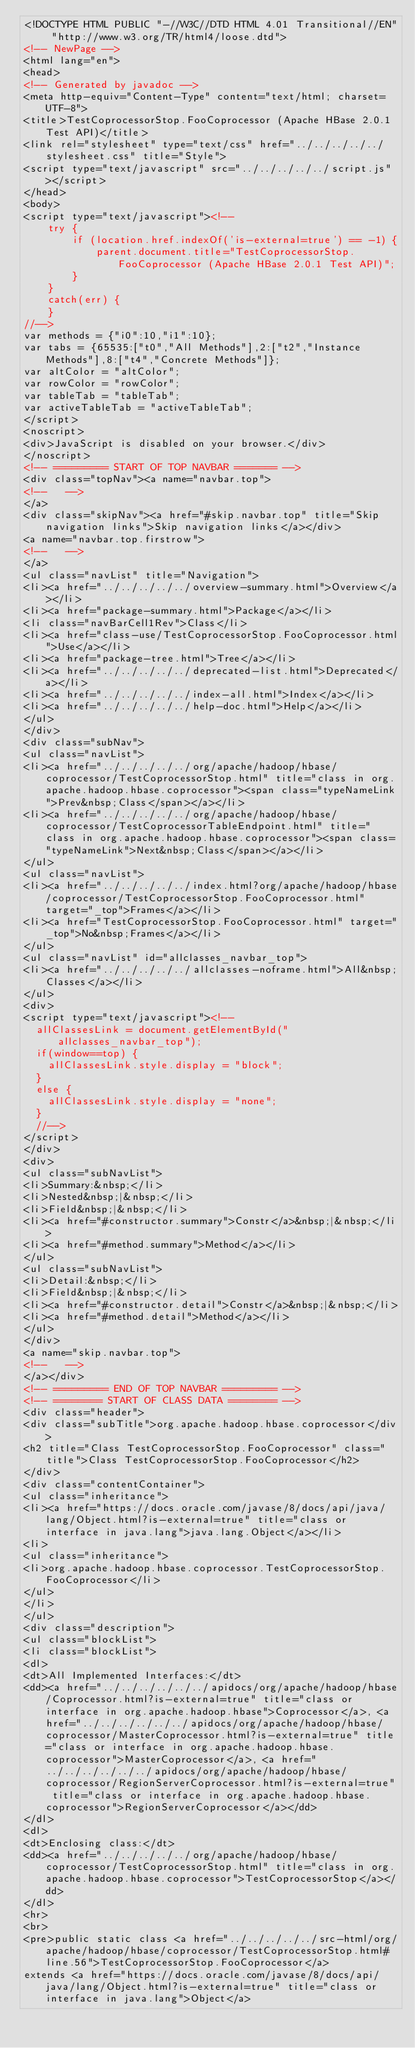Convert code to text. <code><loc_0><loc_0><loc_500><loc_500><_HTML_><!DOCTYPE HTML PUBLIC "-//W3C//DTD HTML 4.01 Transitional//EN" "http://www.w3.org/TR/html4/loose.dtd">
<!-- NewPage -->
<html lang="en">
<head>
<!-- Generated by javadoc -->
<meta http-equiv="Content-Type" content="text/html; charset=UTF-8">
<title>TestCoprocessorStop.FooCoprocessor (Apache HBase 2.0.1 Test API)</title>
<link rel="stylesheet" type="text/css" href="../../../../../stylesheet.css" title="Style">
<script type="text/javascript" src="../../../../../script.js"></script>
</head>
<body>
<script type="text/javascript"><!--
    try {
        if (location.href.indexOf('is-external=true') == -1) {
            parent.document.title="TestCoprocessorStop.FooCoprocessor (Apache HBase 2.0.1 Test API)";
        }
    }
    catch(err) {
    }
//-->
var methods = {"i0":10,"i1":10};
var tabs = {65535:["t0","All Methods"],2:["t2","Instance Methods"],8:["t4","Concrete Methods"]};
var altColor = "altColor";
var rowColor = "rowColor";
var tableTab = "tableTab";
var activeTableTab = "activeTableTab";
</script>
<noscript>
<div>JavaScript is disabled on your browser.</div>
</noscript>
<!-- ========= START OF TOP NAVBAR ======= -->
<div class="topNav"><a name="navbar.top">
<!--   -->
</a>
<div class="skipNav"><a href="#skip.navbar.top" title="Skip navigation links">Skip navigation links</a></div>
<a name="navbar.top.firstrow">
<!--   -->
</a>
<ul class="navList" title="Navigation">
<li><a href="../../../../../overview-summary.html">Overview</a></li>
<li><a href="package-summary.html">Package</a></li>
<li class="navBarCell1Rev">Class</li>
<li><a href="class-use/TestCoprocessorStop.FooCoprocessor.html">Use</a></li>
<li><a href="package-tree.html">Tree</a></li>
<li><a href="../../../../../deprecated-list.html">Deprecated</a></li>
<li><a href="../../../../../index-all.html">Index</a></li>
<li><a href="../../../../../help-doc.html">Help</a></li>
</ul>
</div>
<div class="subNav">
<ul class="navList">
<li><a href="../../../../../org/apache/hadoop/hbase/coprocessor/TestCoprocessorStop.html" title="class in org.apache.hadoop.hbase.coprocessor"><span class="typeNameLink">Prev&nbsp;Class</span></a></li>
<li><a href="../../../../../org/apache/hadoop/hbase/coprocessor/TestCoprocessorTableEndpoint.html" title="class in org.apache.hadoop.hbase.coprocessor"><span class="typeNameLink">Next&nbsp;Class</span></a></li>
</ul>
<ul class="navList">
<li><a href="../../../../../index.html?org/apache/hadoop/hbase/coprocessor/TestCoprocessorStop.FooCoprocessor.html" target="_top">Frames</a></li>
<li><a href="TestCoprocessorStop.FooCoprocessor.html" target="_top">No&nbsp;Frames</a></li>
</ul>
<ul class="navList" id="allclasses_navbar_top">
<li><a href="../../../../../allclasses-noframe.html">All&nbsp;Classes</a></li>
</ul>
<div>
<script type="text/javascript"><!--
  allClassesLink = document.getElementById("allclasses_navbar_top");
  if(window==top) {
    allClassesLink.style.display = "block";
  }
  else {
    allClassesLink.style.display = "none";
  }
  //-->
</script>
</div>
<div>
<ul class="subNavList">
<li>Summary:&nbsp;</li>
<li>Nested&nbsp;|&nbsp;</li>
<li>Field&nbsp;|&nbsp;</li>
<li><a href="#constructor.summary">Constr</a>&nbsp;|&nbsp;</li>
<li><a href="#method.summary">Method</a></li>
</ul>
<ul class="subNavList">
<li>Detail:&nbsp;</li>
<li>Field&nbsp;|&nbsp;</li>
<li><a href="#constructor.detail">Constr</a>&nbsp;|&nbsp;</li>
<li><a href="#method.detail">Method</a></li>
</ul>
</div>
<a name="skip.navbar.top">
<!--   -->
</a></div>
<!-- ========= END OF TOP NAVBAR ========= -->
<!-- ======== START OF CLASS DATA ======== -->
<div class="header">
<div class="subTitle">org.apache.hadoop.hbase.coprocessor</div>
<h2 title="Class TestCoprocessorStop.FooCoprocessor" class="title">Class TestCoprocessorStop.FooCoprocessor</h2>
</div>
<div class="contentContainer">
<ul class="inheritance">
<li><a href="https://docs.oracle.com/javase/8/docs/api/java/lang/Object.html?is-external=true" title="class or interface in java.lang">java.lang.Object</a></li>
<li>
<ul class="inheritance">
<li>org.apache.hadoop.hbase.coprocessor.TestCoprocessorStop.FooCoprocessor</li>
</ul>
</li>
</ul>
<div class="description">
<ul class="blockList">
<li class="blockList">
<dl>
<dt>All Implemented Interfaces:</dt>
<dd><a href="../../../../../../apidocs/org/apache/hadoop/hbase/Coprocessor.html?is-external=true" title="class or interface in org.apache.hadoop.hbase">Coprocessor</a>, <a href="../../../../../../apidocs/org/apache/hadoop/hbase/coprocessor/MasterCoprocessor.html?is-external=true" title="class or interface in org.apache.hadoop.hbase.coprocessor">MasterCoprocessor</a>, <a href="../../../../../../apidocs/org/apache/hadoop/hbase/coprocessor/RegionServerCoprocessor.html?is-external=true" title="class or interface in org.apache.hadoop.hbase.coprocessor">RegionServerCoprocessor</a></dd>
</dl>
<dl>
<dt>Enclosing class:</dt>
<dd><a href="../../../../../org/apache/hadoop/hbase/coprocessor/TestCoprocessorStop.html" title="class in org.apache.hadoop.hbase.coprocessor">TestCoprocessorStop</a></dd>
</dl>
<hr>
<br>
<pre>public static class <a href="../../../../../src-html/org/apache/hadoop/hbase/coprocessor/TestCoprocessorStop.html#line.56">TestCoprocessorStop.FooCoprocessor</a>
extends <a href="https://docs.oracle.com/javase/8/docs/api/java/lang/Object.html?is-external=true" title="class or interface in java.lang">Object</a></code> 